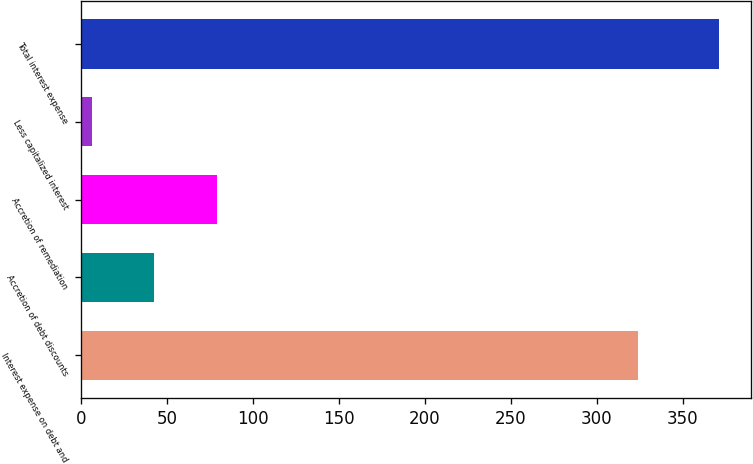Convert chart. <chart><loc_0><loc_0><loc_500><loc_500><bar_chart><fcel>Interest expense on debt and<fcel>Accretion of debt discounts<fcel>Accretion of remediation<fcel>Less capitalized interest<fcel>Total interest expense<nl><fcel>324.1<fcel>42.71<fcel>79.22<fcel>6.2<fcel>371.3<nl></chart> 